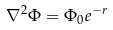<formula> <loc_0><loc_0><loc_500><loc_500>\nabla ^ { 2 } \Phi = \Phi _ { 0 } e ^ { - r }</formula> 